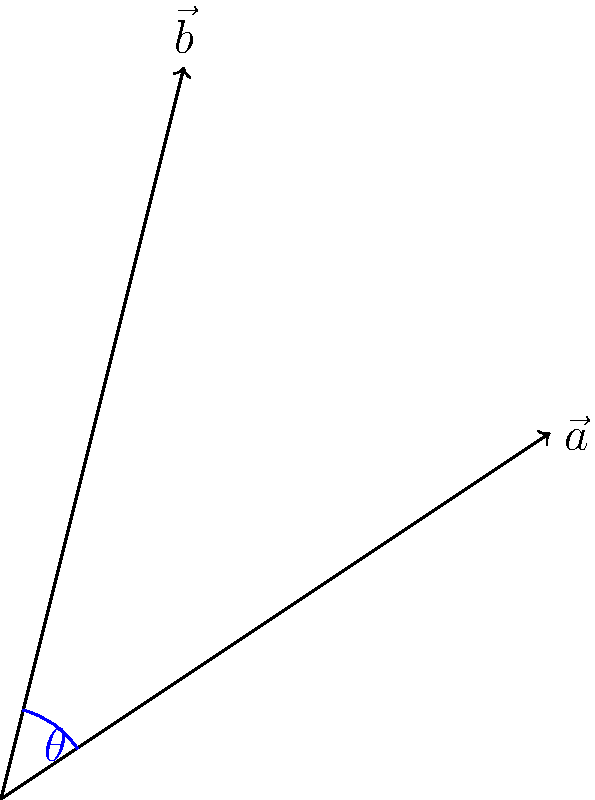In a 2D Cartesian coordinate system, we have two vectors: $\vec{a} = (3, 2)$ and $\vec{b} = (1, 4)$. Calculate the angle $\theta$ between these two vectors using the dot product formula. Express your answer in radians, rounded to two decimal places. To find the angle between two vectors using the dot product formula, we'll follow these steps:

1) The dot product formula for the angle between two vectors is:

   $$\cos \theta = \frac{\vec{a} \cdot \vec{b}}{|\vec{a}||\vec{b}|}$$

2) Calculate the dot product $\vec{a} \cdot \vec{b}$:
   $$\vec{a} \cdot \vec{b} = (3 \times 1) + (2 \times 4) = 3 + 8 = 11$$

3) Calculate the magnitudes of the vectors:
   $$|\vec{a}| = \sqrt{3^2 + 2^2} = \sqrt{13}$$
   $$|\vec{b}| = \sqrt{1^2 + 4^2} = \sqrt{17}$$

4) Substitute these values into the formula:
   $$\cos \theta = \frac{11}{\sqrt{13} \times \sqrt{17}}$$

5) Calculate the right-hand side:
   $$\cos \theta = \frac{11}{\sqrt{221}} \approx 0.7396$$

6) Take the inverse cosine (arccos) of both sides:
   $$\theta = \arccos(\frac{11}{\sqrt{221}}) \approx 0.7354 \text{ radians}$$

7) Rounding to two decimal places:
   $$\theta \approx 0.74 \text{ radians}$$
Answer: 0.74 radians 